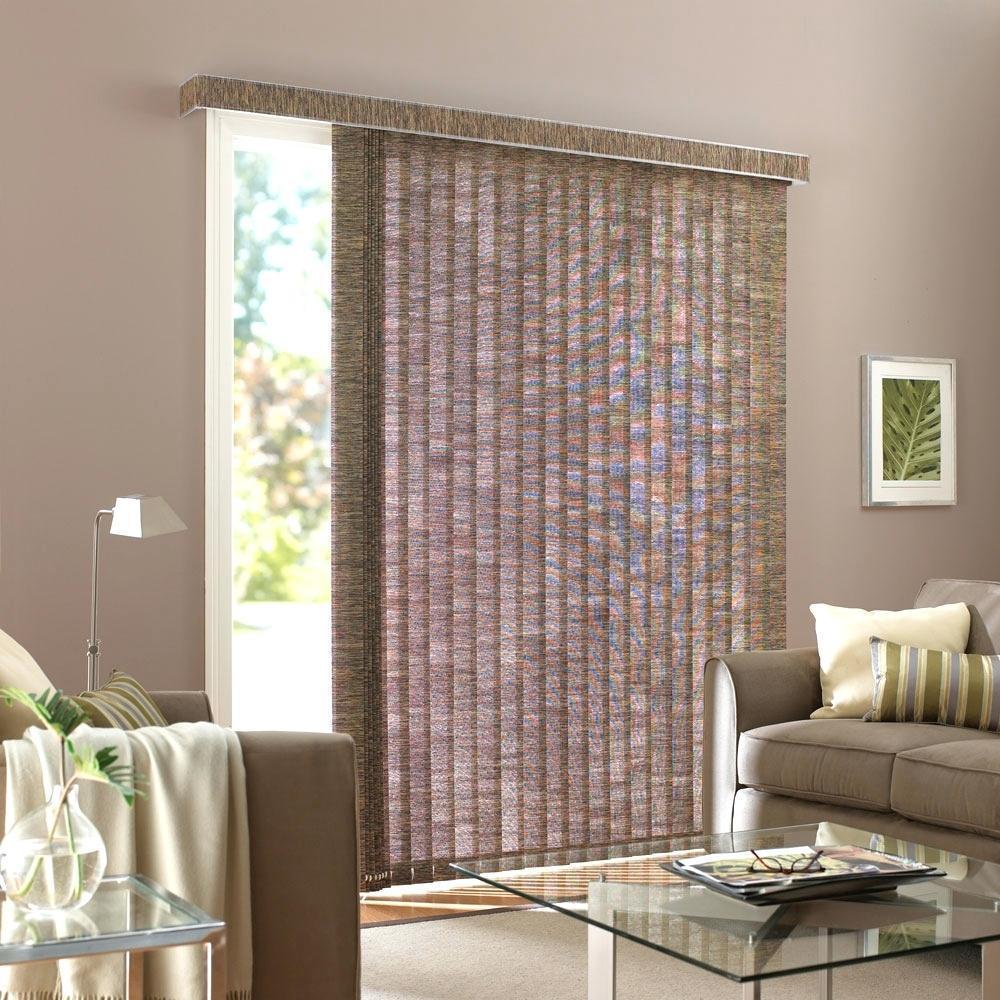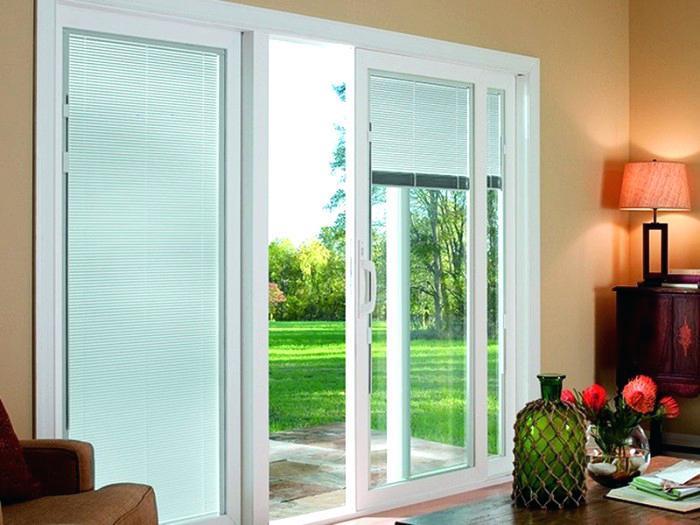The first image is the image on the left, the second image is the image on the right. Evaluate the accuracy of this statement regarding the images: "There are two beds (any part of a bed) in front of whitish blinds.". Is it true? Answer yes or no. No. The first image is the image on the left, the second image is the image on the right. Evaluate the accuracy of this statement regarding the images: "There is a sofa/chair near the tall window, in the left image.". Is it true? Answer yes or no. Yes. 